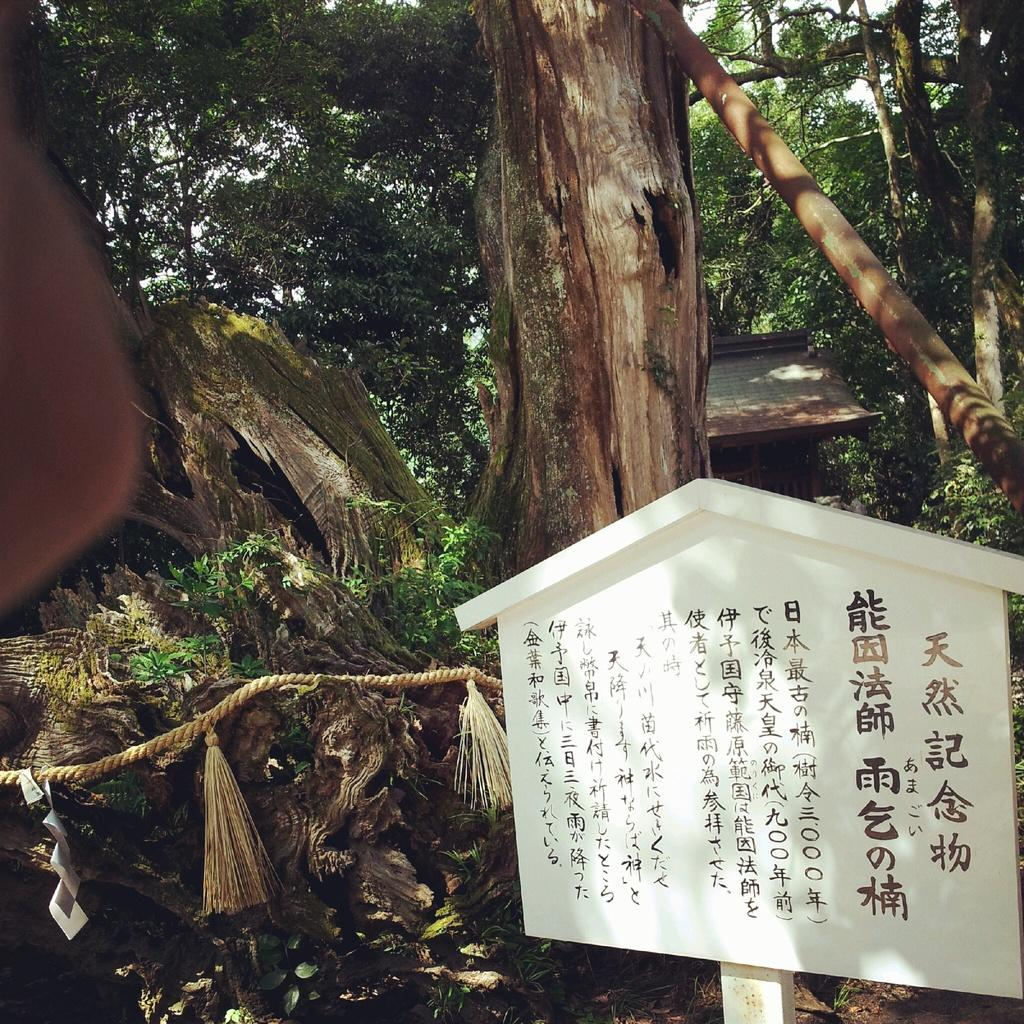What is the main object in the front of the image? There is a board with text in the front of the image. What can be seen in the center of the image? There is a rope in the center of the image. What type of natural environment is visible in the background of the image? There are trees in the background of the image. What type of structure is visible in the background of the image? There is a wall in the background of the image. What is the rate at which the honey is dripping from the board in the image? There is no honey present in the image, so it is not possible to determine the rate at which it might be dripping. 